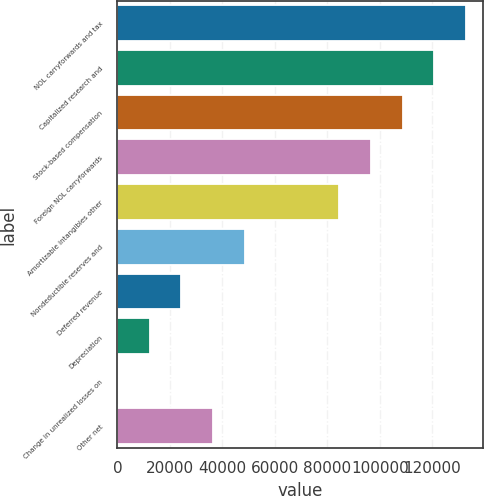Convert chart to OTSL. <chart><loc_0><loc_0><loc_500><loc_500><bar_chart><fcel>NOL carryforwards and tax<fcel>Capitalized research and<fcel>Stock-based compensation<fcel>Foreign NOL carryforwards<fcel>Amortizable intangibles other<fcel>Nondeductible reserves and<fcel>Deferred revenue<fcel>Depreciation<fcel>Change in unrealized losses on<fcel>Other net<nl><fcel>132764<fcel>120721<fcel>108678<fcel>96635.6<fcel>84592.9<fcel>48464.8<fcel>24379.4<fcel>12336.7<fcel>294<fcel>36422.1<nl></chart> 